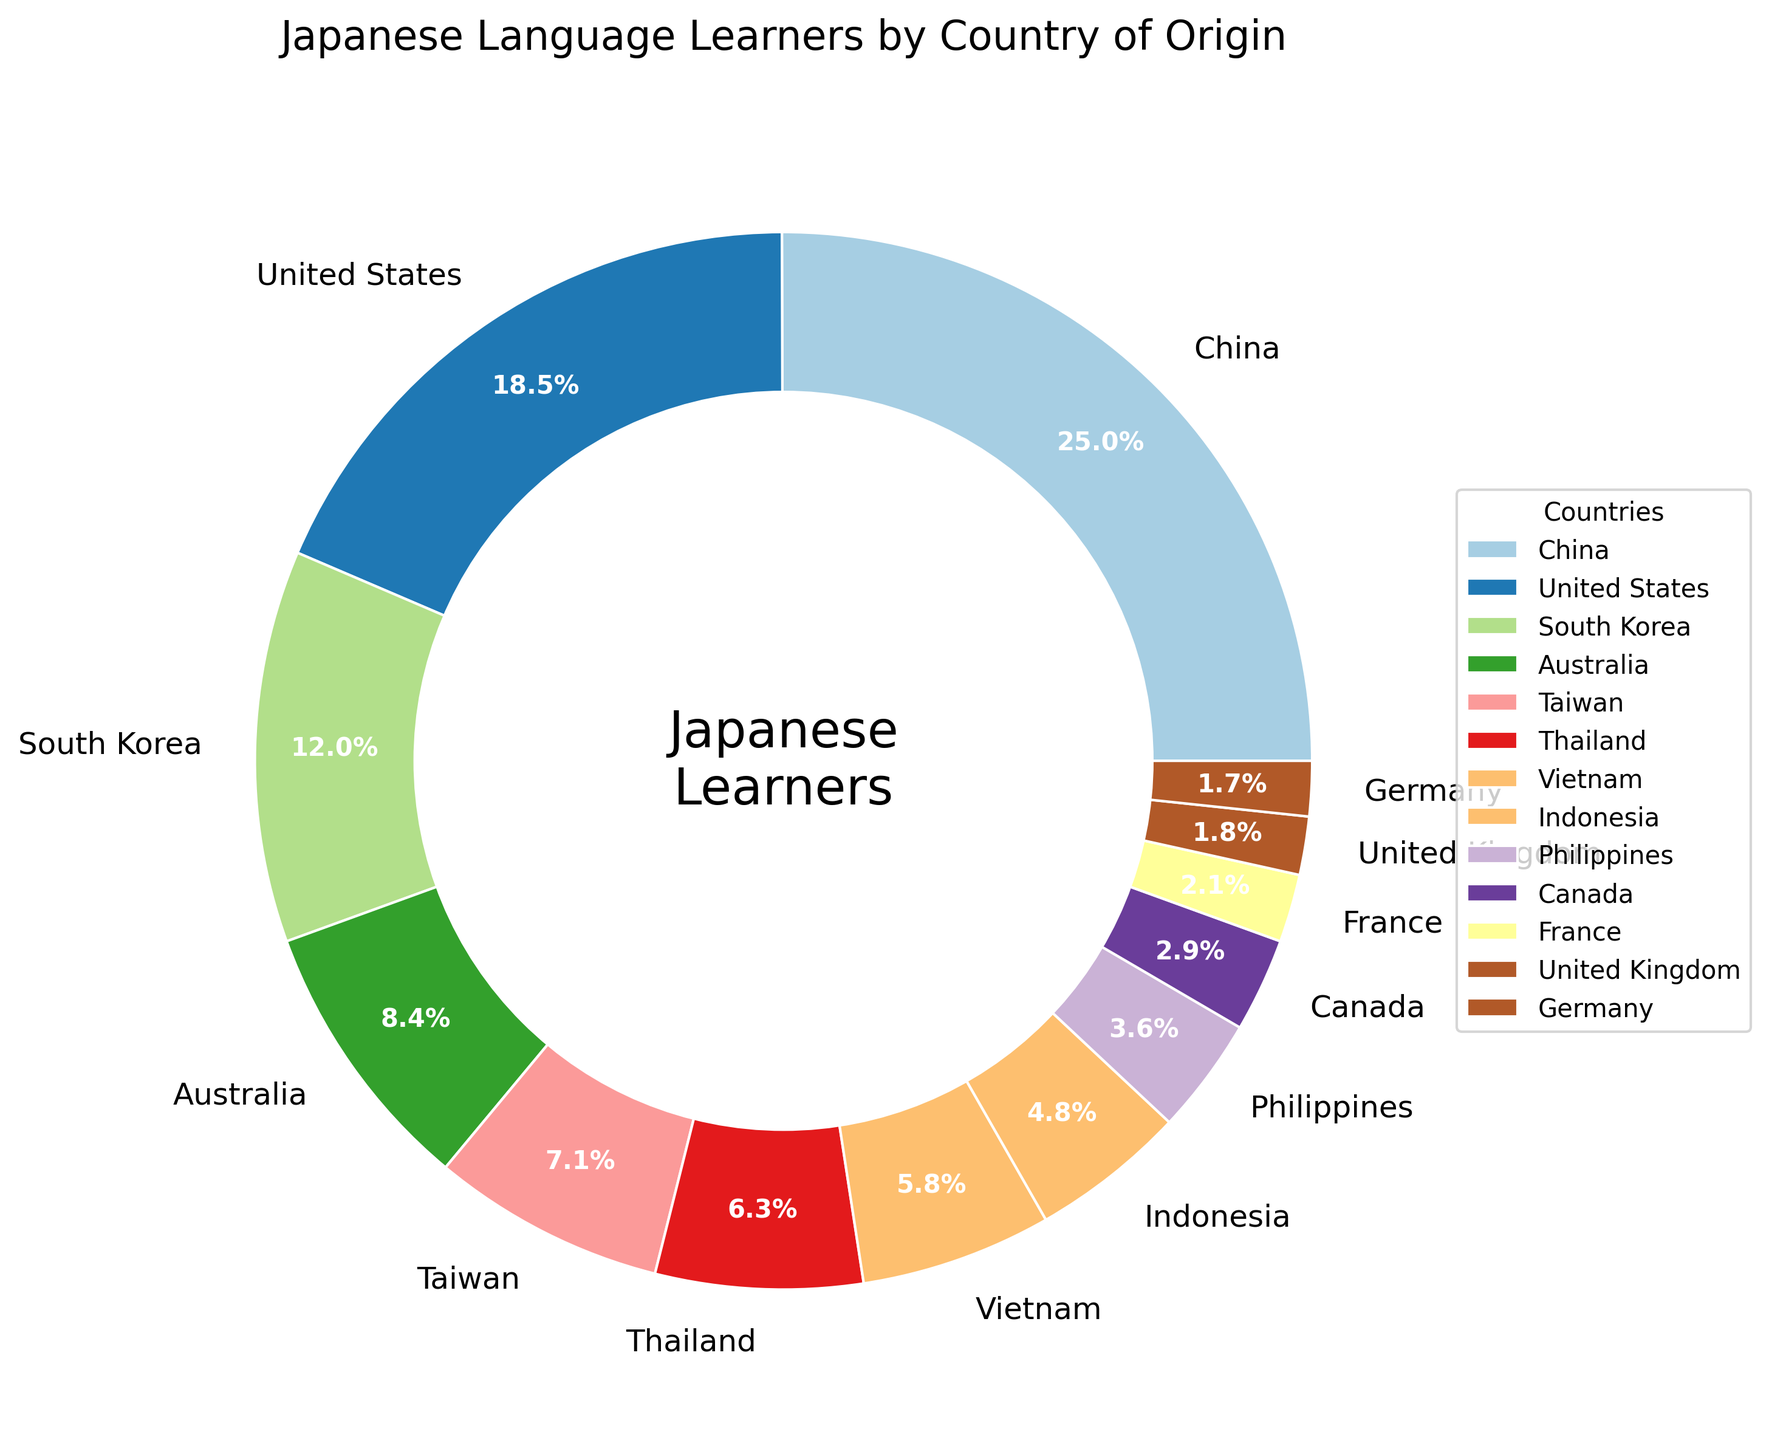What percentage of Japanese language learners come from China and the United States combined? To find the combined percentage of learners from China and the United States, sum the individual percentages of each country. China's percentage is 25.3% and the United States' percentage is 18.7%, thus 25.3% + 18.7% = 44.0%.
Answer: 44.0% Which country has the second highest percentage of Japanese language learners? The highest percentage is from China (25.3%). The second highest percentage is from the United States, which is 18.7%.
Answer: United States Is Thailand's percentage of Japanese language learners more or less than Taiwan's? To compare the percentages, note that Thailand has 6.4% and Taiwan has 7.2%. Thailand's percentage is less than Taiwan's.
Answer: Less Between South Korea and Vietnam, which has a smaller percentage of Japanese language learners and by how much? South Korea has 12.1% and Vietnam has 5.9%. Subtract Vietnam's percentage from South Korea's percentage: 12.1% - 5.9% = 6.2%.
Answer: Vietnam, 6.2% What is the total percentage of Japanese language learners from Australia, Canada, and the United Kingdom combined? To get the total percentage, add the percentages from Australia (8.5%), Canada (2.9%), and the United Kingdom (1.8%): 8.5% + 2.9% + 1.8% = 13.2%.
Answer: 13.2% Which country has a larger percentage of Japanese language learners, Indonesia or France? Indonesia has 4.8% and France has 2.1%. Comparing these values, Indonesia has a larger percentage.
Answer: Indonesia What percentage of Japanese language learners come from countries with less than 5% representation each? Identify countries with less than 5%: Philippines (3.6%), Canada (2.9%), France (2.1%), United Kingdom (1.8%), and Germany (1.7%). Sum these percentages: 3.6% + 2.9% + 2.1% + 1.8% + 1.7% = 12.1%.
Answer: 12.1% Which two countries combined have a percentage closest to that of the United States? Comparing data, Vietnam (5.9%) and Australia (8.5%) together make up 14.4%, which is closest to the United States' 18.7% compared to other combinations.
Answer: Vietnam and Australia 